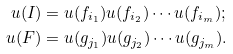Convert formula to latex. <formula><loc_0><loc_0><loc_500><loc_500>u ( I ) & = u ( f _ { i _ { 1 } } ) u ( f _ { i _ { 2 } } ) \cdots u ( f _ { i _ { m } } ) ; \\ u ( F ) & = u ( g _ { j _ { 1 } } ) u ( g _ { j _ { 2 } } ) \cdots u ( g _ { j _ { m } } ) .</formula> 